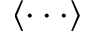<formula> <loc_0><loc_0><loc_500><loc_500>\langle \cdot \cdot \cdot \rangle</formula> 